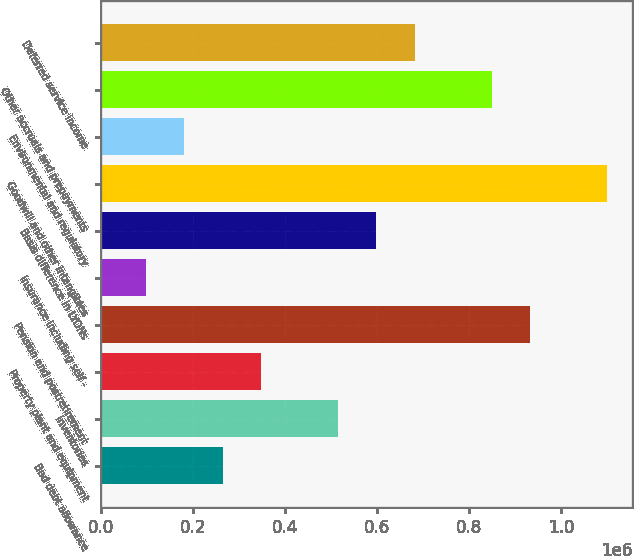Convert chart to OTSL. <chart><loc_0><loc_0><loc_500><loc_500><bar_chart><fcel>Bad debt allowance<fcel>Inventories<fcel>Property plant and equipment<fcel>Pension and postretirement<fcel>Insurance including self -<fcel>Basis difference in LYONs<fcel>Goodwill and other intangibles<fcel>Environmental and regulatory<fcel>Other accruals and prepayments<fcel>Deferred service income<nl><fcel>264900<fcel>515406<fcel>348402<fcel>932916<fcel>97896<fcel>598908<fcel>1.09992e+06<fcel>181398<fcel>849414<fcel>682410<nl></chart> 